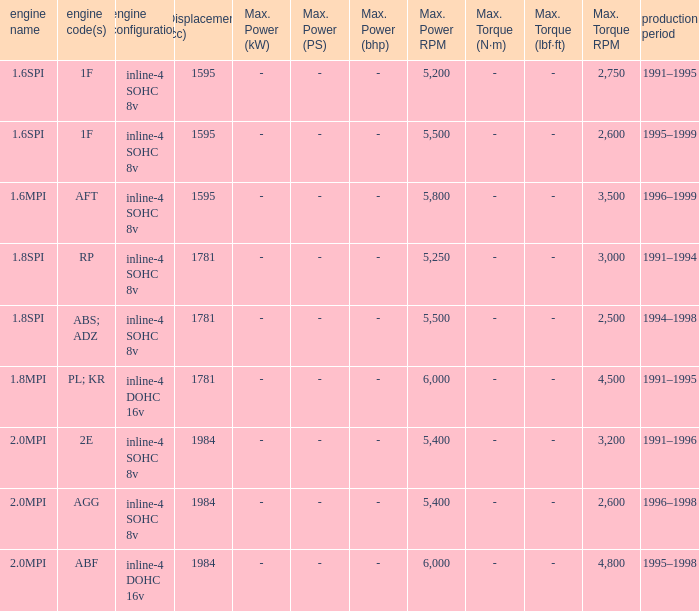What is the maximum power of engine code 2e? Kw (ps; bhp) @ 5,400. 